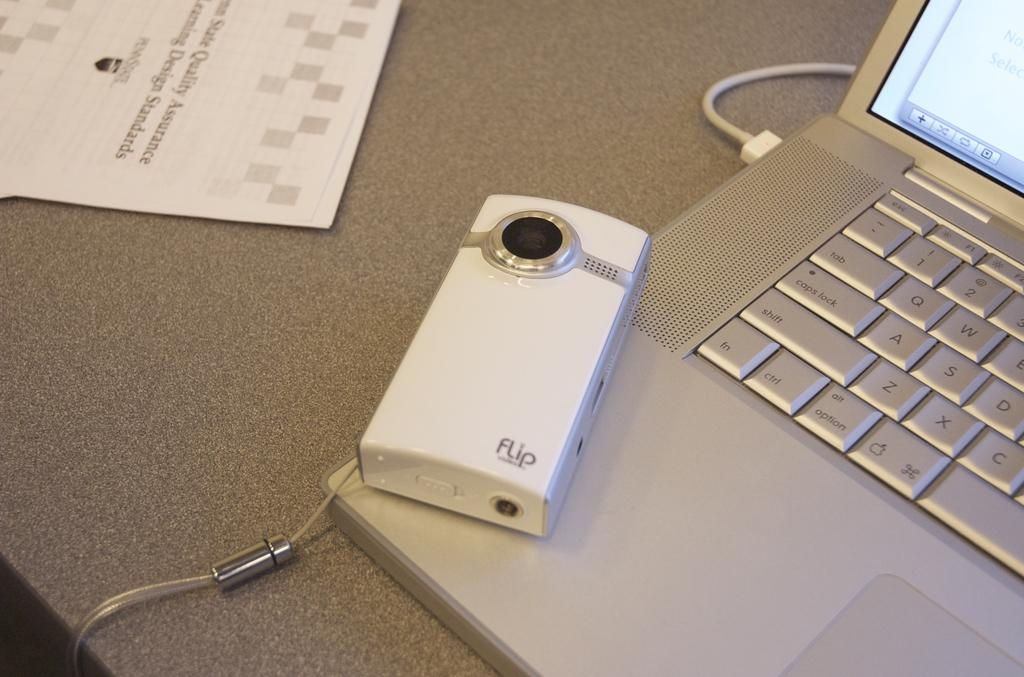<image>
Write a terse but informative summary of the picture. A device able to take photos placed on a laptop, with the device having the word "flip" on it. 